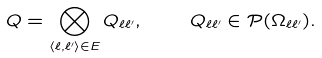<formula> <loc_0><loc_0><loc_500><loc_500>Q = \bigotimes _ { \langle \ell , \ell ^ { \prime } \rangle \in E } Q _ { \ell \ell ^ { \prime } } , \quad Q _ { \ell \ell ^ { \prime } } \in \mathcal { P } ( \Omega _ { \ell \ell ^ { \prime } } ) .</formula> 